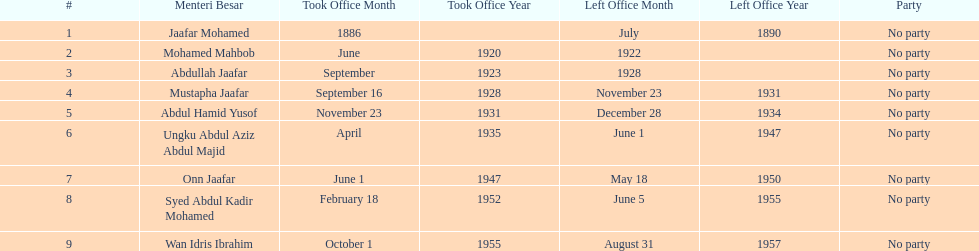Who took office after abdullah jaafar? Mustapha Jaafar. 